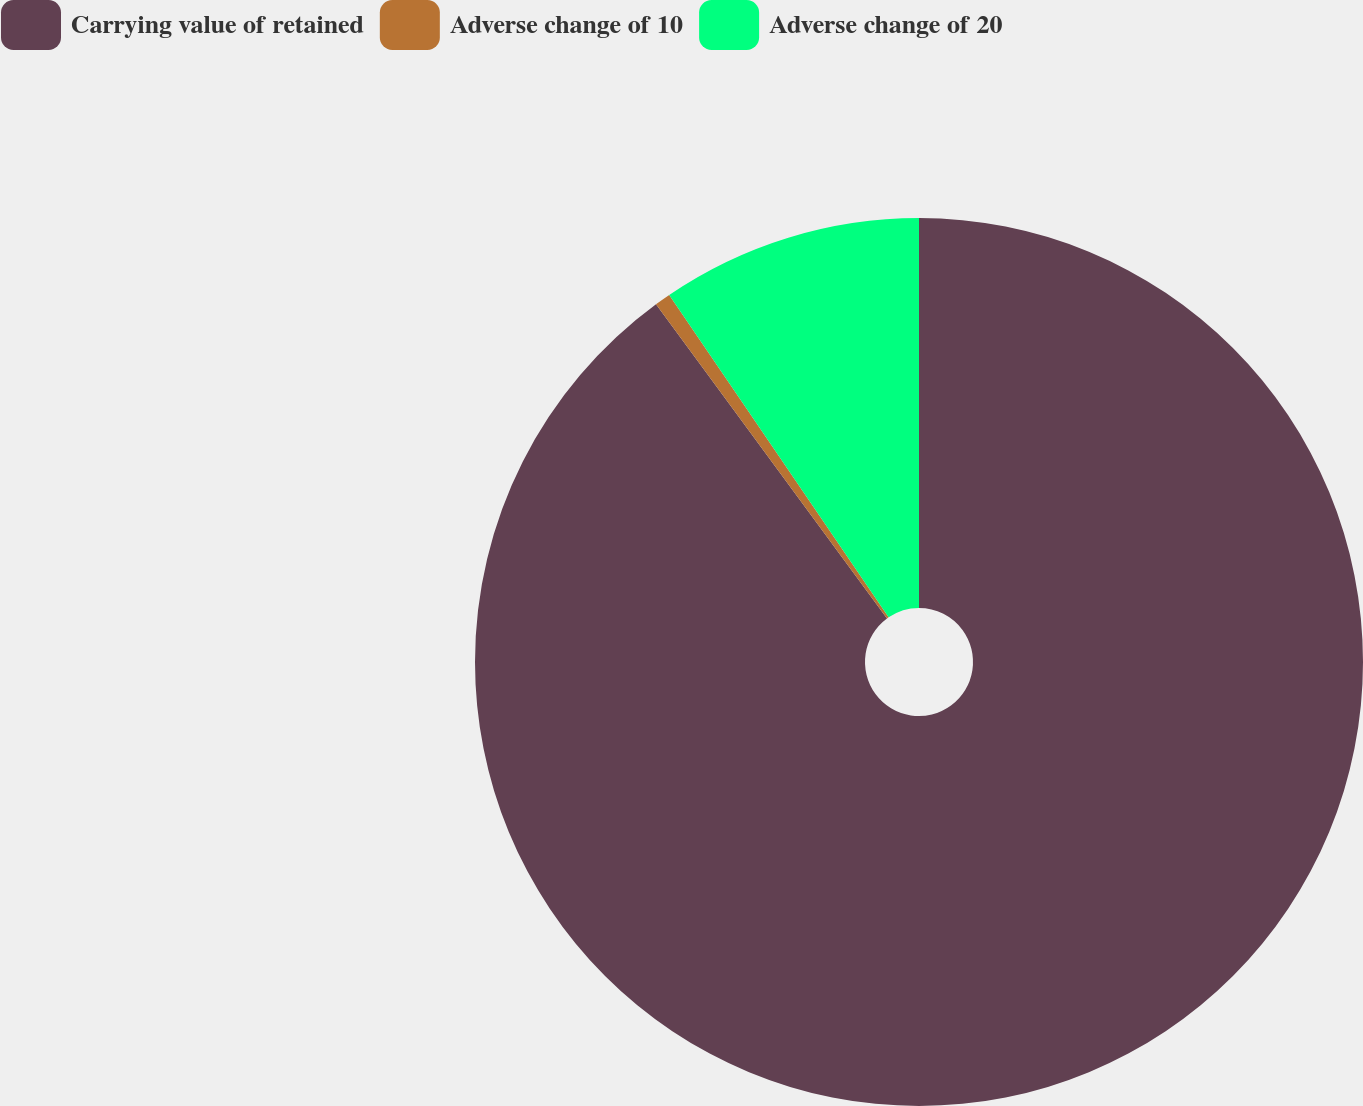Convert chart to OTSL. <chart><loc_0><loc_0><loc_500><loc_500><pie_chart><fcel>Carrying value of retained<fcel>Adverse change of 10<fcel>Adverse change of 20<nl><fcel>89.91%<fcel>0.58%<fcel>9.51%<nl></chart> 